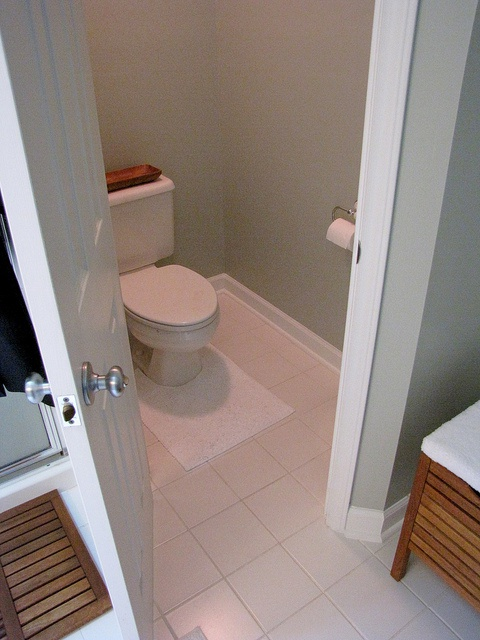Describe the objects in this image and their specific colors. I can see a toilet in gray and darkgray tones in this image. 